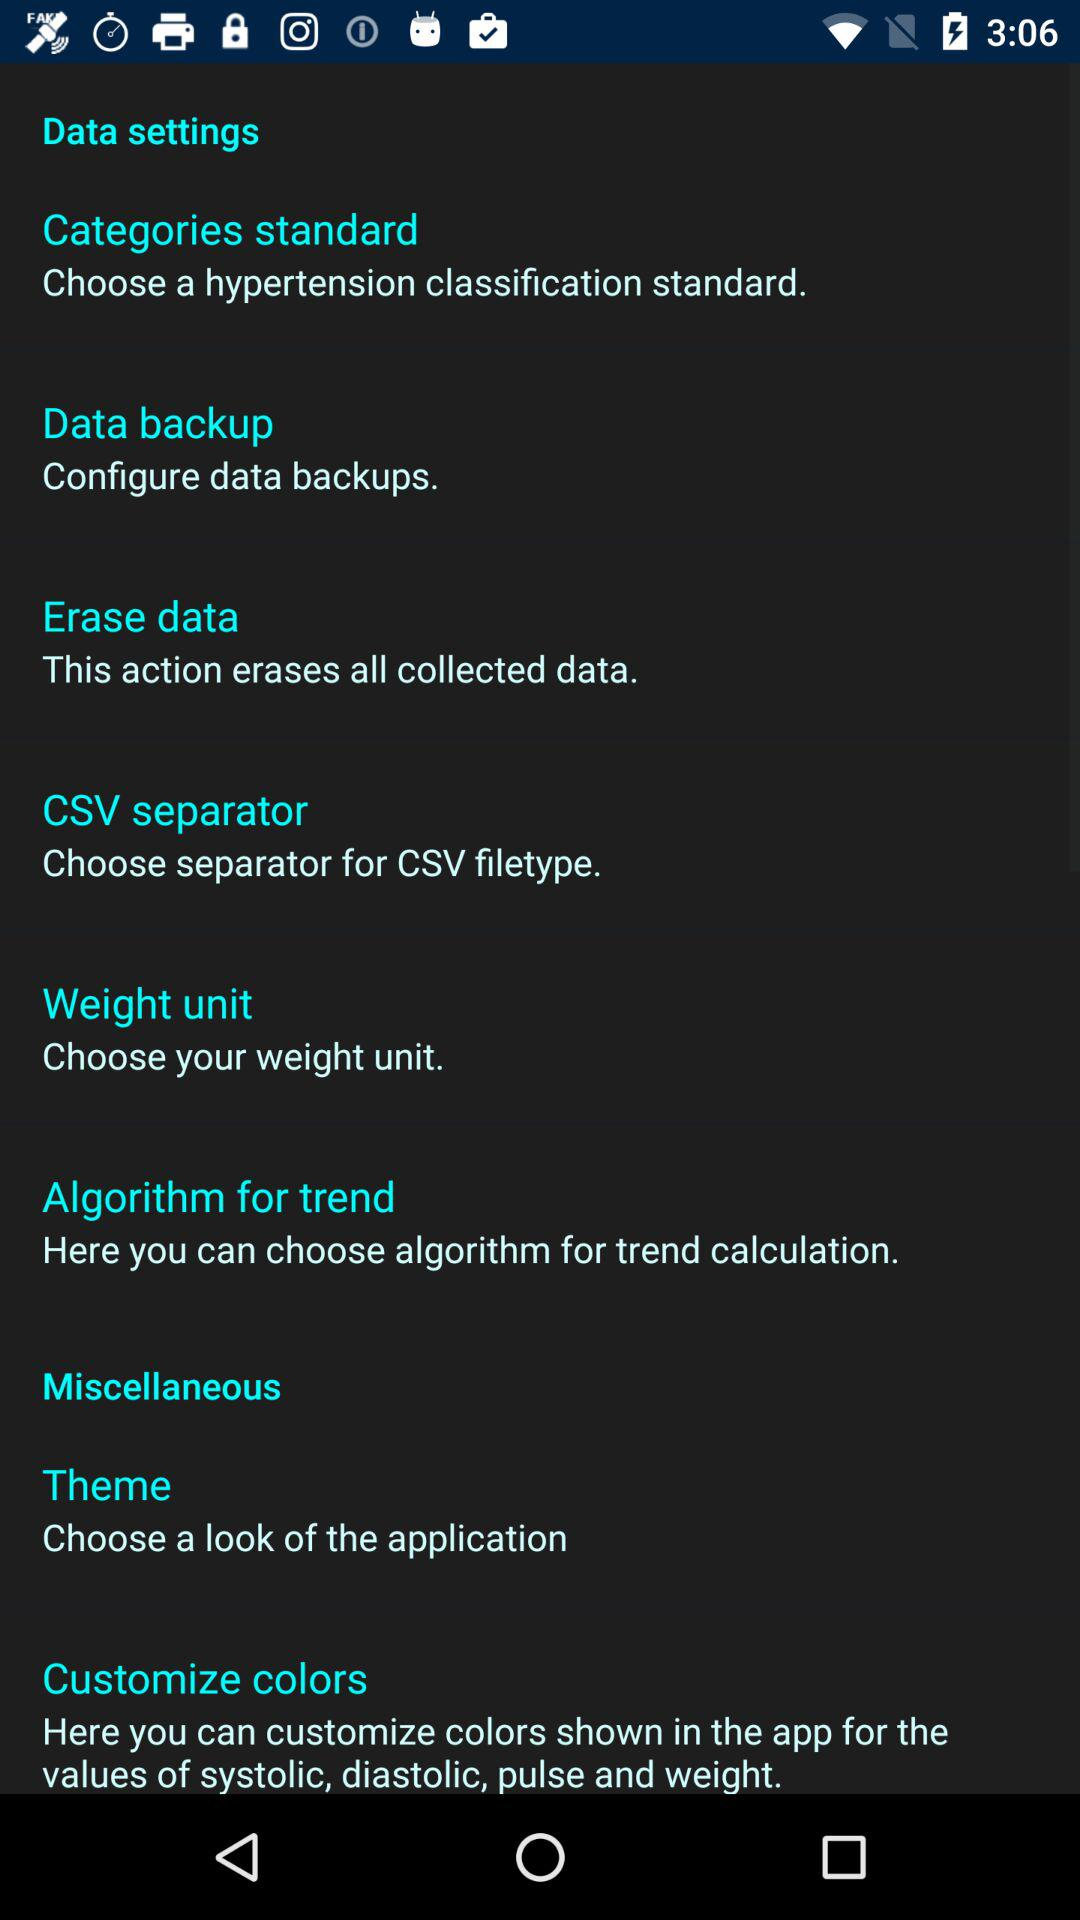What is the work of "Erase data"? The work of "Erase data" is to erase all collected data. 